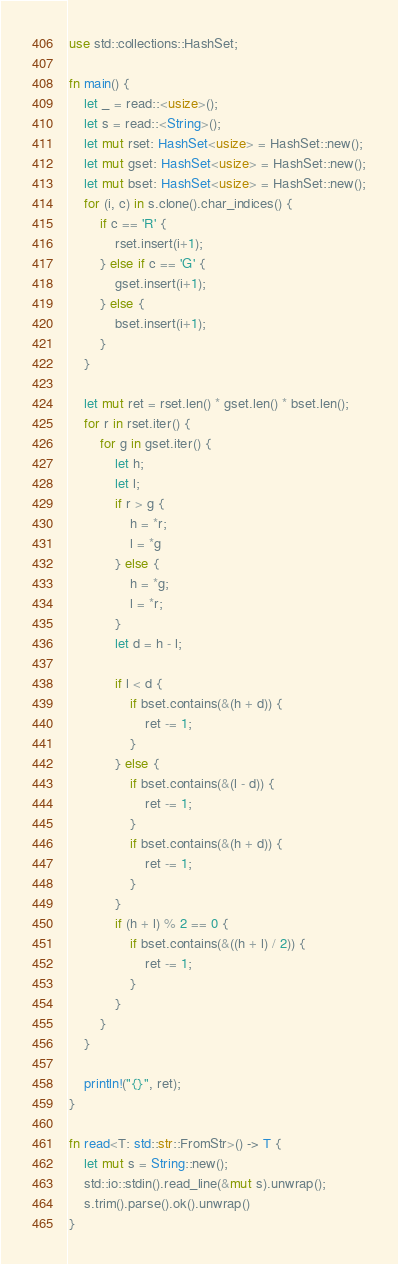Convert code to text. <code><loc_0><loc_0><loc_500><loc_500><_Rust_>use std::collections::HashSet;

fn main() {
    let _ = read::<usize>();
    let s = read::<String>();
    let mut rset: HashSet<usize> = HashSet::new();
    let mut gset: HashSet<usize> = HashSet::new();
    let mut bset: HashSet<usize> = HashSet::new();
    for (i, c) in s.clone().char_indices() {
        if c == 'R' {
            rset.insert(i+1);
        } else if c == 'G' {
            gset.insert(i+1);
        } else {
            bset.insert(i+1);
        }
    }

    let mut ret = rset.len() * gset.len() * bset.len();
    for r in rset.iter() {
        for g in gset.iter() {
            let h;
            let l;
            if r > g {
                h = *r;
                l = *g
            } else {
                h = *g;
                l = *r;
            }
            let d = h - l;

            if l < d {
                if bset.contains(&(h + d)) {
                    ret -= 1;
                }
            } else {
                if bset.contains(&(l - d)) {
                    ret -= 1;
                }
                if bset.contains(&(h + d)) {
                    ret -= 1;
                }
            }
            if (h + l) % 2 == 0 {
                if bset.contains(&((h + l) / 2)) {
                    ret -= 1;
                }
            }
        }
    }

    println!("{}", ret);
}

fn read<T: std::str::FromStr>() -> T {
    let mut s = String::new();
    std::io::stdin().read_line(&mut s).unwrap();
    s.trim().parse().ok().unwrap()
}
</code> 